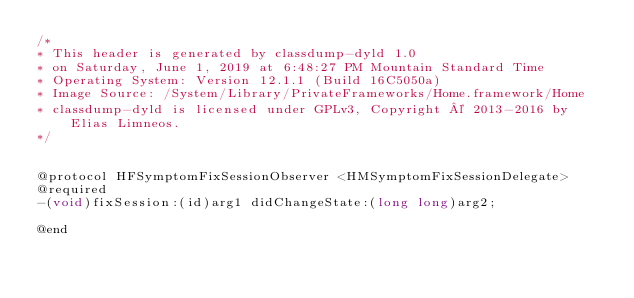Convert code to text. <code><loc_0><loc_0><loc_500><loc_500><_C_>/*
* This header is generated by classdump-dyld 1.0
* on Saturday, June 1, 2019 at 6:48:27 PM Mountain Standard Time
* Operating System: Version 12.1.1 (Build 16C5050a)
* Image Source: /System/Library/PrivateFrameworks/Home.framework/Home
* classdump-dyld is licensed under GPLv3, Copyright © 2013-2016 by Elias Limneos.
*/


@protocol HFSymptomFixSessionObserver <HMSymptomFixSessionDelegate>
@required
-(void)fixSession:(id)arg1 didChangeState:(long long)arg2;

@end

</code> 